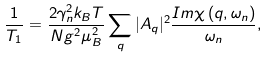Convert formula to latex. <formula><loc_0><loc_0><loc_500><loc_500>\frac { 1 } { T _ { 1 } } = \frac { 2 \gamma _ { n } ^ { 2 } k _ { B } T } { N g ^ { 2 } \mu _ { B } ^ { 2 } } \sum _ { q } | A _ { q } | ^ { 2 } \frac { I m \chi \left ( { q } , \omega _ { n } \right ) } { \omega _ { n } } ,</formula> 